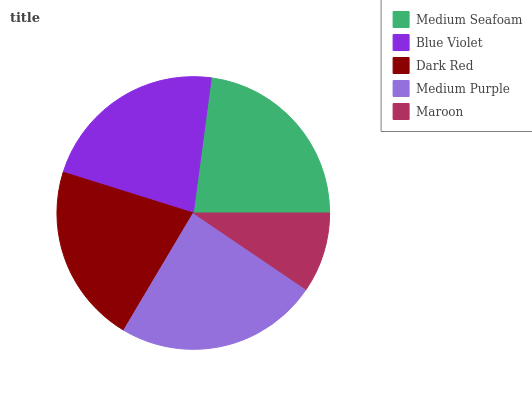Is Maroon the minimum?
Answer yes or no. Yes. Is Medium Purple the maximum?
Answer yes or no. Yes. Is Blue Violet the minimum?
Answer yes or no. No. Is Blue Violet the maximum?
Answer yes or no. No. Is Medium Seafoam greater than Blue Violet?
Answer yes or no. Yes. Is Blue Violet less than Medium Seafoam?
Answer yes or no. Yes. Is Blue Violet greater than Medium Seafoam?
Answer yes or no. No. Is Medium Seafoam less than Blue Violet?
Answer yes or no. No. Is Blue Violet the high median?
Answer yes or no. Yes. Is Blue Violet the low median?
Answer yes or no. Yes. Is Medium Seafoam the high median?
Answer yes or no. No. Is Maroon the low median?
Answer yes or no. No. 